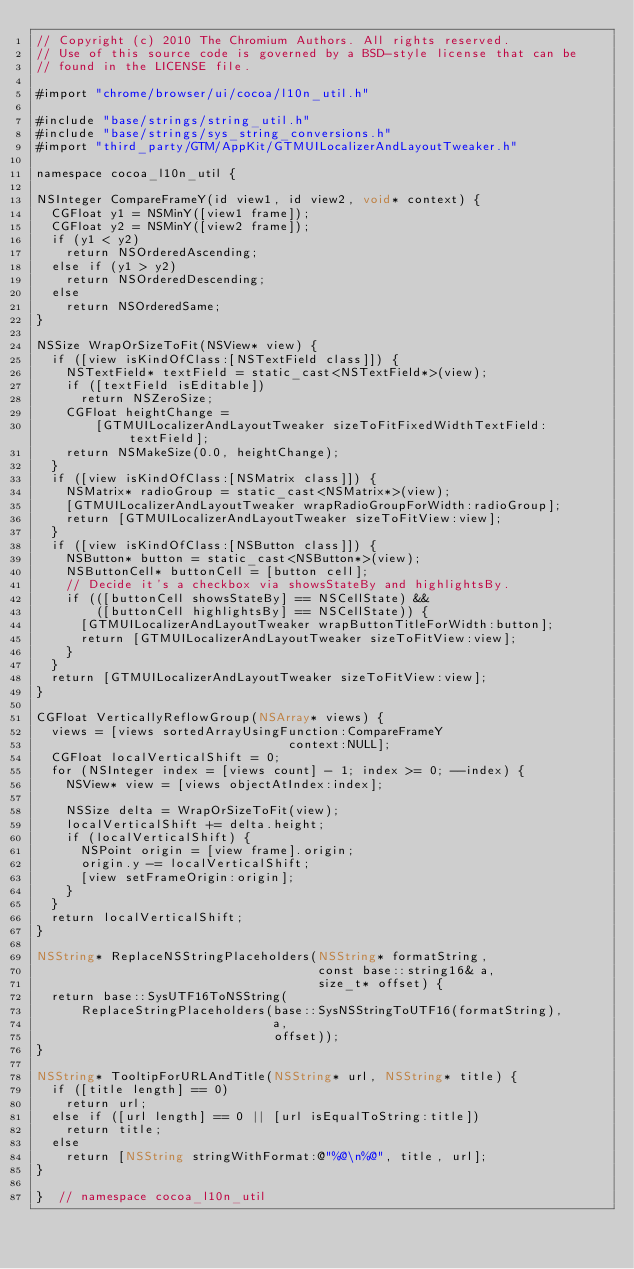Convert code to text. <code><loc_0><loc_0><loc_500><loc_500><_ObjectiveC_>// Copyright (c) 2010 The Chromium Authors. All rights reserved.
// Use of this source code is governed by a BSD-style license that can be
// found in the LICENSE file.

#import "chrome/browser/ui/cocoa/l10n_util.h"

#include "base/strings/string_util.h"
#include "base/strings/sys_string_conversions.h"
#import "third_party/GTM/AppKit/GTMUILocalizerAndLayoutTweaker.h"

namespace cocoa_l10n_util {

NSInteger CompareFrameY(id view1, id view2, void* context) {
  CGFloat y1 = NSMinY([view1 frame]);
  CGFloat y2 = NSMinY([view2 frame]);
  if (y1 < y2)
    return NSOrderedAscending;
  else if (y1 > y2)
    return NSOrderedDescending;
  else
    return NSOrderedSame;
}

NSSize WrapOrSizeToFit(NSView* view) {
  if ([view isKindOfClass:[NSTextField class]]) {
    NSTextField* textField = static_cast<NSTextField*>(view);
    if ([textField isEditable])
      return NSZeroSize;
    CGFloat heightChange =
        [GTMUILocalizerAndLayoutTweaker sizeToFitFixedWidthTextField:textField];
    return NSMakeSize(0.0, heightChange);
  }
  if ([view isKindOfClass:[NSMatrix class]]) {
    NSMatrix* radioGroup = static_cast<NSMatrix*>(view);
    [GTMUILocalizerAndLayoutTweaker wrapRadioGroupForWidth:radioGroup];
    return [GTMUILocalizerAndLayoutTweaker sizeToFitView:view];
  }
  if ([view isKindOfClass:[NSButton class]]) {
    NSButton* button = static_cast<NSButton*>(view);
    NSButtonCell* buttonCell = [button cell];
    // Decide it's a checkbox via showsStateBy and highlightsBy.
    if (([buttonCell showsStateBy] == NSCellState) &&
        ([buttonCell highlightsBy] == NSCellState)) {
      [GTMUILocalizerAndLayoutTweaker wrapButtonTitleForWidth:button];
      return [GTMUILocalizerAndLayoutTweaker sizeToFitView:view];
    }
  }
  return [GTMUILocalizerAndLayoutTweaker sizeToFitView:view];
}

CGFloat VerticallyReflowGroup(NSArray* views) {
  views = [views sortedArrayUsingFunction:CompareFrameY
                                  context:NULL];
  CGFloat localVerticalShift = 0;
  for (NSInteger index = [views count] - 1; index >= 0; --index) {
    NSView* view = [views objectAtIndex:index];

    NSSize delta = WrapOrSizeToFit(view);
    localVerticalShift += delta.height;
    if (localVerticalShift) {
      NSPoint origin = [view frame].origin;
      origin.y -= localVerticalShift;
      [view setFrameOrigin:origin];
    }
  }
  return localVerticalShift;
}

NSString* ReplaceNSStringPlaceholders(NSString* formatString,
                                      const base::string16& a,
                                      size_t* offset) {
  return base::SysUTF16ToNSString(
      ReplaceStringPlaceholders(base::SysNSStringToUTF16(formatString),
                                a,
                                offset));
}

NSString* TooltipForURLAndTitle(NSString* url, NSString* title) {
  if ([title length] == 0)
    return url;
  else if ([url length] == 0 || [url isEqualToString:title])
    return title;
  else
    return [NSString stringWithFormat:@"%@\n%@", title, url];
}

}  // namespace cocoa_l10n_util
</code> 